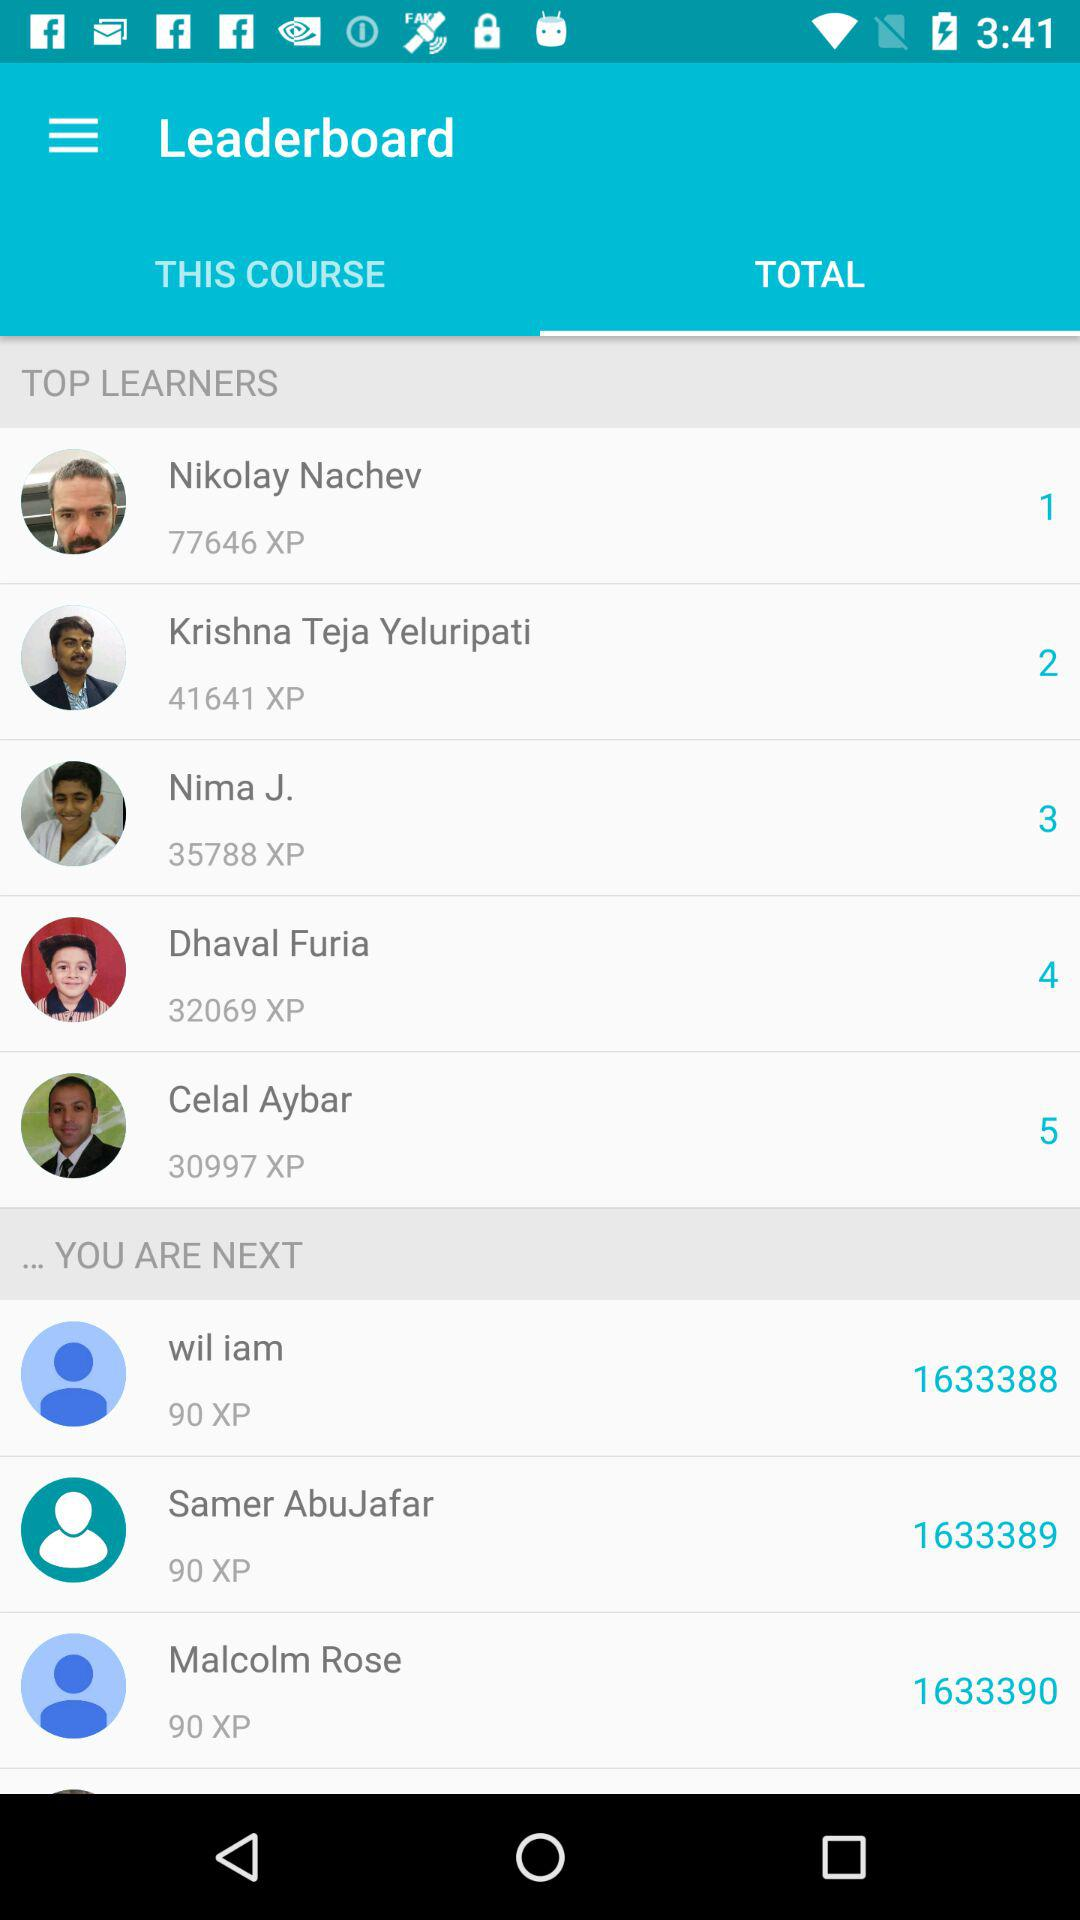Which person has ranked 1? The person who has been ranked 1 is Nikolay Nachev. 